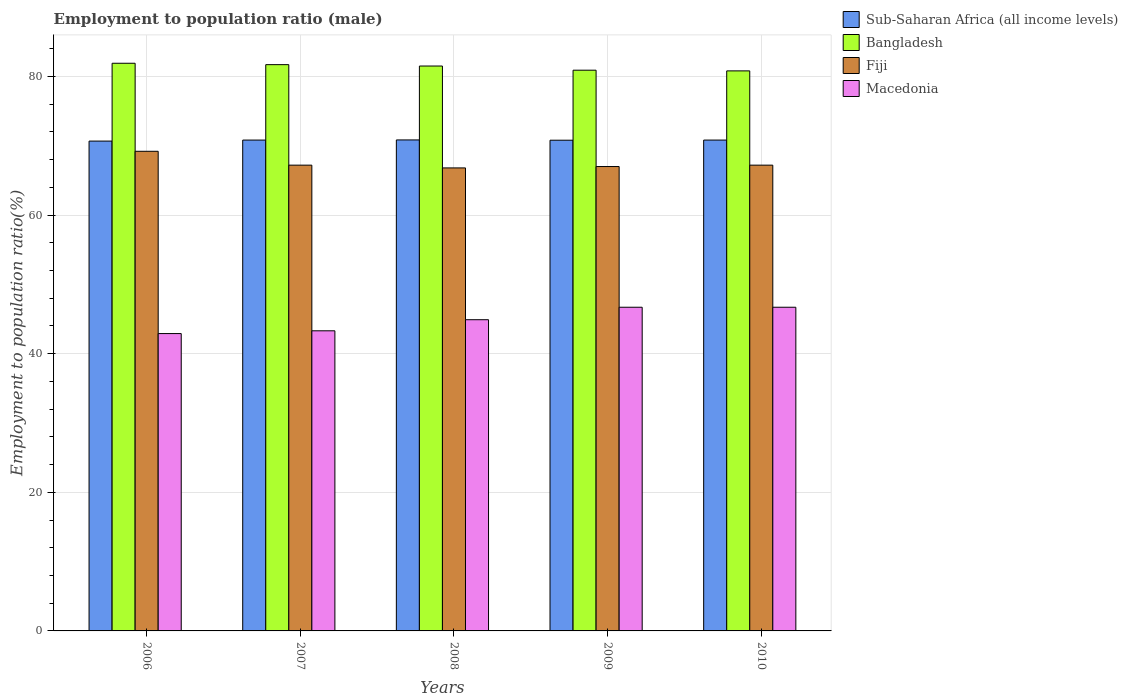How many groups of bars are there?
Your answer should be very brief. 5. Are the number of bars per tick equal to the number of legend labels?
Your answer should be very brief. Yes. How many bars are there on the 1st tick from the left?
Ensure brevity in your answer.  4. What is the label of the 2nd group of bars from the left?
Make the answer very short. 2007. In how many cases, is the number of bars for a given year not equal to the number of legend labels?
Keep it short and to the point. 0. What is the employment to population ratio in Macedonia in 2007?
Your response must be concise. 43.3. Across all years, what is the maximum employment to population ratio in Sub-Saharan Africa (all income levels)?
Offer a terse response. 70.84. Across all years, what is the minimum employment to population ratio in Bangladesh?
Your response must be concise. 80.8. In which year was the employment to population ratio in Fiji minimum?
Your answer should be compact. 2008. What is the total employment to population ratio in Fiji in the graph?
Keep it short and to the point. 337.4. What is the difference between the employment to population ratio in Fiji in 2007 and that in 2009?
Provide a short and direct response. 0.2. What is the difference between the employment to population ratio in Fiji in 2008 and the employment to population ratio in Macedonia in 2009?
Your answer should be very brief. 20.1. What is the average employment to population ratio in Fiji per year?
Your response must be concise. 67.48. In the year 2009, what is the difference between the employment to population ratio in Sub-Saharan Africa (all income levels) and employment to population ratio in Fiji?
Your answer should be very brief. 3.8. In how many years, is the employment to population ratio in Macedonia greater than 36 %?
Ensure brevity in your answer.  5. What is the ratio of the employment to population ratio in Macedonia in 2006 to that in 2010?
Your answer should be compact. 0.92. Is the difference between the employment to population ratio in Sub-Saharan Africa (all income levels) in 2006 and 2010 greater than the difference between the employment to population ratio in Fiji in 2006 and 2010?
Your response must be concise. No. What is the difference between the highest and the second highest employment to population ratio in Bangladesh?
Keep it short and to the point. 0.2. What is the difference between the highest and the lowest employment to population ratio in Bangladesh?
Your answer should be compact. 1.1. Is the sum of the employment to population ratio in Sub-Saharan Africa (all income levels) in 2007 and 2008 greater than the maximum employment to population ratio in Fiji across all years?
Offer a very short reply. Yes. What does the 1st bar from the left in 2006 represents?
Your response must be concise. Sub-Saharan Africa (all income levels). Is it the case that in every year, the sum of the employment to population ratio in Bangladesh and employment to population ratio in Macedonia is greater than the employment to population ratio in Sub-Saharan Africa (all income levels)?
Your response must be concise. Yes. How many bars are there?
Make the answer very short. 20. How many years are there in the graph?
Your answer should be compact. 5. Does the graph contain grids?
Your response must be concise. Yes. How are the legend labels stacked?
Keep it short and to the point. Vertical. What is the title of the graph?
Ensure brevity in your answer.  Employment to population ratio (male). Does "Korea (Democratic)" appear as one of the legend labels in the graph?
Offer a terse response. No. What is the label or title of the X-axis?
Offer a very short reply. Years. What is the Employment to population ratio(%) of Sub-Saharan Africa (all income levels) in 2006?
Ensure brevity in your answer.  70.67. What is the Employment to population ratio(%) in Bangladesh in 2006?
Provide a succinct answer. 81.9. What is the Employment to population ratio(%) in Fiji in 2006?
Offer a terse response. 69.2. What is the Employment to population ratio(%) in Macedonia in 2006?
Make the answer very short. 42.9. What is the Employment to population ratio(%) in Sub-Saharan Africa (all income levels) in 2007?
Your answer should be compact. 70.82. What is the Employment to population ratio(%) in Bangladesh in 2007?
Provide a succinct answer. 81.7. What is the Employment to population ratio(%) in Fiji in 2007?
Offer a terse response. 67.2. What is the Employment to population ratio(%) in Macedonia in 2007?
Offer a very short reply. 43.3. What is the Employment to population ratio(%) of Sub-Saharan Africa (all income levels) in 2008?
Give a very brief answer. 70.84. What is the Employment to population ratio(%) of Bangladesh in 2008?
Your answer should be very brief. 81.5. What is the Employment to population ratio(%) in Fiji in 2008?
Provide a short and direct response. 66.8. What is the Employment to population ratio(%) of Macedonia in 2008?
Give a very brief answer. 44.9. What is the Employment to population ratio(%) of Sub-Saharan Africa (all income levels) in 2009?
Offer a terse response. 70.8. What is the Employment to population ratio(%) in Bangladesh in 2009?
Your answer should be compact. 80.9. What is the Employment to population ratio(%) in Fiji in 2009?
Provide a short and direct response. 67. What is the Employment to population ratio(%) of Macedonia in 2009?
Give a very brief answer. 46.7. What is the Employment to population ratio(%) in Sub-Saharan Africa (all income levels) in 2010?
Offer a very short reply. 70.82. What is the Employment to population ratio(%) in Bangladesh in 2010?
Ensure brevity in your answer.  80.8. What is the Employment to population ratio(%) of Fiji in 2010?
Offer a terse response. 67.2. What is the Employment to population ratio(%) of Macedonia in 2010?
Ensure brevity in your answer.  46.7. Across all years, what is the maximum Employment to population ratio(%) in Sub-Saharan Africa (all income levels)?
Keep it short and to the point. 70.84. Across all years, what is the maximum Employment to population ratio(%) of Bangladesh?
Offer a terse response. 81.9. Across all years, what is the maximum Employment to population ratio(%) in Fiji?
Give a very brief answer. 69.2. Across all years, what is the maximum Employment to population ratio(%) of Macedonia?
Keep it short and to the point. 46.7. Across all years, what is the minimum Employment to population ratio(%) of Sub-Saharan Africa (all income levels)?
Ensure brevity in your answer.  70.67. Across all years, what is the minimum Employment to population ratio(%) in Bangladesh?
Make the answer very short. 80.8. Across all years, what is the minimum Employment to population ratio(%) of Fiji?
Your response must be concise. 66.8. Across all years, what is the minimum Employment to population ratio(%) in Macedonia?
Provide a short and direct response. 42.9. What is the total Employment to population ratio(%) in Sub-Saharan Africa (all income levels) in the graph?
Offer a terse response. 353.94. What is the total Employment to population ratio(%) of Bangladesh in the graph?
Offer a terse response. 406.8. What is the total Employment to population ratio(%) of Fiji in the graph?
Provide a short and direct response. 337.4. What is the total Employment to population ratio(%) in Macedonia in the graph?
Your answer should be compact. 224.5. What is the difference between the Employment to population ratio(%) in Sub-Saharan Africa (all income levels) in 2006 and that in 2007?
Make the answer very short. -0.15. What is the difference between the Employment to population ratio(%) of Fiji in 2006 and that in 2007?
Provide a succinct answer. 2. What is the difference between the Employment to population ratio(%) of Macedonia in 2006 and that in 2007?
Provide a short and direct response. -0.4. What is the difference between the Employment to population ratio(%) in Sub-Saharan Africa (all income levels) in 2006 and that in 2008?
Offer a very short reply. -0.17. What is the difference between the Employment to population ratio(%) of Macedonia in 2006 and that in 2008?
Ensure brevity in your answer.  -2. What is the difference between the Employment to population ratio(%) of Sub-Saharan Africa (all income levels) in 2006 and that in 2009?
Offer a terse response. -0.12. What is the difference between the Employment to population ratio(%) of Fiji in 2006 and that in 2009?
Your answer should be very brief. 2.2. What is the difference between the Employment to population ratio(%) of Sub-Saharan Africa (all income levels) in 2006 and that in 2010?
Provide a succinct answer. -0.15. What is the difference between the Employment to population ratio(%) of Bangladesh in 2006 and that in 2010?
Keep it short and to the point. 1.1. What is the difference between the Employment to population ratio(%) of Fiji in 2006 and that in 2010?
Your answer should be very brief. 2. What is the difference between the Employment to population ratio(%) in Sub-Saharan Africa (all income levels) in 2007 and that in 2008?
Your answer should be compact. -0.02. What is the difference between the Employment to population ratio(%) of Bangladesh in 2007 and that in 2008?
Offer a terse response. 0.2. What is the difference between the Employment to population ratio(%) in Fiji in 2007 and that in 2008?
Offer a very short reply. 0.4. What is the difference between the Employment to population ratio(%) of Sub-Saharan Africa (all income levels) in 2007 and that in 2009?
Make the answer very short. 0.02. What is the difference between the Employment to population ratio(%) in Bangladesh in 2007 and that in 2009?
Your answer should be compact. 0.8. What is the difference between the Employment to population ratio(%) of Fiji in 2007 and that in 2009?
Give a very brief answer. 0.2. What is the difference between the Employment to population ratio(%) in Macedonia in 2007 and that in 2009?
Ensure brevity in your answer.  -3.4. What is the difference between the Employment to population ratio(%) in Sub-Saharan Africa (all income levels) in 2007 and that in 2010?
Offer a very short reply. -0. What is the difference between the Employment to population ratio(%) of Bangladesh in 2007 and that in 2010?
Ensure brevity in your answer.  0.9. What is the difference between the Employment to population ratio(%) in Sub-Saharan Africa (all income levels) in 2008 and that in 2009?
Make the answer very short. 0.04. What is the difference between the Employment to population ratio(%) of Fiji in 2008 and that in 2009?
Make the answer very short. -0.2. What is the difference between the Employment to population ratio(%) in Sub-Saharan Africa (all income levels) in 2008 and that in 2010?
Provide a short and direct response. 0.02. What is the difference between the Employment to population ratio(%) in Bangladesh in 2008 and that in 2010?
Provide a short and direct response. 0.7. What is the difference between the Employment to population ratio(%) of Sub-Saharan Africa (all income levels) in 2009 and that in 2010?
Ensure brevity in your answer.  -0.02. What is the difference between the Employment to population ratio(%) of Bangladesh in 2009 and that in 2010?
Your answer should be very brief. 0.1. What is the difference between the Employment to population ratio(%) of Sub-Saharan Africa (all income levels) in 2006 and the Employment to population ratio(%) of Bangladesh in 2007?
Offer a very short reply. -11.03. What is the difference between the Employment to population ratio(%) of Sub-Saharan Africa (all income levels) in 2006 and the Employment to population ratio(%) of Fiji in 2007?
Ensure brevity in your answer.  3.47. What is the difference between the Employment to population ratio(%) in Sub-Saharan Africa (all income levels) in 2006 and the Employment to population ratio(%) in Macedonia in 2007?
Offer a terse response. 27.37. What is the difference between the Employment to population ratio(%) of Bangladesh in 2006 and the Employment to population ratio(%) of Macedonia in 2007?
Keep it short and to the point. 38.6. What is the difference between the Employment to population ratio(%) in Fiji in 2006 and the Employment to population ratio(%) in Macedonia in 2007?
Keep it short and to the point. 25.9. What is the difference between the Employment to population ratio(%) of Sub-Saharan Africa (all income levels) in 2006 and the Employment to population ratio(%) of Bangladesh in 2008?
Ensure brevity in your answer.  -10.83. What is the difference between the Employment to population ratio(%) in Sub-Saharan Africa (all income levels) in 2006 and the Employment to population ratio(%) in Fiji in 2008?
Offer a terse response. 3.87. What is the difference between the Employment to population ratio(%) of Sub-Saharan Africa (all income levels) in 2006 and the Employment to population ratio(%) of Macedonia in 2008?
Your answer should be very brief. 25.77. What is the difference between the Employment to population ratio(%) of Bangladesh in 2006 and the Employment to population ratio(%) of Fiji in 2008?
Your answer should be compact. 15.1. What is the difference between the Employment to population ratio(%) of Fiji in 2006 and the Employment to population ratio(%) of Macedonia in 2008?
Provide a succinct answer. 24.3. What is the difference between the Employment to population ratio(%) of Sub-Saharan Africa (all income levels) in 2006 and the Employment to population ratio(%) of Bangladesh in 2009?
Your response must be concise. -10.23. What is the difference between the Employment to population ratio(%) of Sub-Saharan Africa (all income levels) in 2006 and the Employment to population ratio(%) of Fiji in 2009?
Give a very brief answer. 3.67. What is the difference between the Employment to population ratio(%) of Sub-Saharan Africa (all income levels) in 2006 and the Employment to population ratio(%) of Macedonia in 2009?
Provide a succinct answer. 23.97. What is the difference between the Employment to population ratio(%) of Bangladesh in 2006 and the Employment to population ratio(%) of Fiji in 2009?
Offer a very short reply. 14.9. What is the difference between the Employment to population ratio(%) of Bangladesh in 2006 and the Employment to population ratio(%) of Macedonia in 2009?
Give a very brief answer. 35.2. What is the difference between the Employment to population ratio(%) in Fiji in 2006 and the Employment to population ratio(%) in Macedonia in 2009?
Make the answer very short. 22.5. What is the difference between the Employment to population ratio(%) in Sub-Saharan Africa (all income levels) in 2006 and the Employment to population ratio(%) in Bangladesh in 2010?
Keep it short and to the point. -10.13. What is the difference between the Employment to population ratio(%) in Sub-Saharan Africa (all income levels) in 2006 and the Employment to population ratio(%) in Fiji in 2010?
Provide a succinct answer. 3.47. What is the difference between the Employment to population ratio(%) of Sub-Saharan Africa (all income levels) in 2006 and the Employment to population ratio(%) of Macedonia in 2010?
Give a very brief answer. 23.97. What is the difference between the Employment to population ratio(%) in Bangladesh in 2006 and the Employment to population ratio(%) in Fiji in 2010?
Your answer should be compact. 14.7. What is the difference between the Employment to population ratio(%) in Bangladesh in 2006 and the Employment to population ratio(%) in Macedonia in 2010?
Your response must be concise. 35.2. What is the difference between the Employment to population ratio(%) of Sub-Saharan Africa (all income levels) in 2007 and the Employment to population ratio(%) of Bangladesh in 2008?
Offer a terse response. -10.68. What is the difference between the Employment to population ratio(%) in Sub-Saharan Africa (all income levels) in 2007 and the Employment to population ratio(%) in Fiji in 2008?
Make the answer very short. 4.02. What is the difference between the Employment to population ratio(%) of Sub-Saharan Africa (all income levels) in 2007 and the Employment to population ratio(%) of Macedonia in 2008?
Your answer should be very brief. 25.92. What is the difference between the Employment to population ratio(%) in Bangladesh in 2007 and the Employment to population ratio(%) in Macedonia in 2008?
Provide a short and direct response. 36.8. What is the difference between the Employment to population ratio(%) in Fiji in 2007 and the Employment to population ratio(%) in Macedonia in 2008?
Offer a very short reply. 22.3. What is the difference between the Employment to population ratio(%) in Sub-Saharan Africa (all income levels) in 2007 and the Employment to population ratio(%) in Bangladesh in 2009?
Your answer should be very brief. -10.08. What is the difference between the Employment to population ratio(%) of Sub-Saharan Africa (all income levels) in 2007 and the Employment to population ratio(%) of Fiji in 2009?
Make the answer very short. 3.82. What is the difference between the Employment to population ratio(%) of Sub-Saharan Africa (all income levels) in 2007 and the Employment to population ratio(%) of Macedonia in 2009?
Provide a short and direct response. 24.12. What is the difference between the Employment to population ratio(%) in Bangladesh in 2007 and the Employment to population ratio(%) in Fiji in 2009?
Provide a short and direct response. 14.7. What is the difference between the Employment to population ratio(%) in Fiji in 2007 and the Employment to population ratio(%) in Macedonia in 2009?
Your response must be concise. 20.5. What is the difference between the Employment to population ratio(%) of Sub-Saharan Africa (all income levels) in 2007 and the Employment to population ratio(%) of Bangladesh in 2010?
Your answer should be compact. -9.98. What is the difference between the Employment to population ratio(%) in Sub-Saharan Africa (all income levels) in 2007 and the Employment to population ratio(%) in Fiji in 2010?
Give a very brief answer. 3.62. What is the difference between the Employment to population ratio(%) of Sub-Saharan Africa (all income levels) in 2007 and the Employment to population ratio(%) of Macedonia in 2010?
Your response must be concise. 24.12. What is the difference between the Employment to population ratio(%) in Bangladesh in 2007 and the Employment to population ratio(%) in Macedonia in 2010?
Provide a succinct answer. 35. What is the difference between the Employment to population ratio(%) of Fiji in 2007 and the Employment to population ratio(%) of Macedonia in 2010?
Keep it short and to the point. 20.5. What is the difference between the Employment to population ratio(%) of Sub-Saharan Africa (all income levels) in 2008 and the Employment to population ratio(%) of Bangladesh in 2009?
Your answer should be compact. -10.06. What is the difference between the Employment to population ratio(%) in Sub-Saharan Africa (all income levels) in 2008 and the Employment to population ratio(%) in Fiji in 2009?
Keep it short and to the point. 3.84. What is the difference between the Employment to population ratio(%) in Sub-Saharan Africa (all income levels) in 2008 and the Employment to population ratio(%) in Macedonia in 2009?
Offer a terse response. 24.14. What is the difference between the Employment to population ratio(%) in Bangladesh in 2008 and the Employment to population ratio(%) in Fiji in 2009?
Your answer should be very brief. 14.5. What is the difference between the Employment to population ratio(%) of Bangladesh in 2008 and the Employment to population ratio(%) of Macedonia in 2009?
Offer a very short reply. 34.8. What is the difference between the Employment to population ratio(%) in Fiji in 2008 and the Employment to population ratio(%) in Macedonia in 2009?
Give a very brief answer. 20.1. What is the difference between the Employment to population ratio(%) of Sub-Saharan Africa (all income levels) in 2008 and the Employment to population ratio(%) of Bangladesh in 2010?
Offer a very short reply. -9.96. What is the difference between the Employment to population ratio(%) of Sub-Saharan Africa (all income levels) in 2008 and the Employment to population ratio(%) of Fiji in 2010?
Offer a very short reply. 3.64. What is the difference between the Employment to population ratio(%) in Sub-Saharan Africa (all income levels) in 2008 and the Employment to population ratio(%) in Macedonia in 2010?
Make the answer very short. 24.14. What is the difference between the Employment to population ratio(%) in Bangladesh in 2008 and the Employment to population ratio(%) in Fiji in 2010?
Give a very brief answer. 14.3. What is the difference between the Employment to population ratio(%) in Bangladesh in 2008 and the Employment to population ratio(%) in Macedonia in 2010?
Provide a succinct answer. 34.8. What is the difference between the Employment to population ratio(%) of Fiji in 2008 and the Employment to population ratio(%) of Macedonia in 2010?
Offer a terse response. 20.1. What is the difference between the Employment to population ratio(%) of Sub-Saharan Africa (all income levels) in 2009 and the Employment to population ratio(%) of Bangladesh in 2010?
Ensure brevity in your answer.  -10. What is the difference between the Employment to population ratio(%) of Sub-Saharan Africa (all income levels) in 2009 and the Employment to population ratio(%) of Fiji in 2010?
Provide a succinct answer. 3.6. What is the difference between the Employment to population ratio(%) in Sub-Saharan Africa (all income levels) in 2009 and the Employment to population ratio(%) in Macedonia in 2010?
Provide a succinct answer. 24.1. What is the difference between the Employment to population ratio(%) in Bangladesh in 2009 and the Employment to population ratio(%) in Fiji in 2010?
Keep it short and to the point. 13.7. What is the difference between the Employment to population ratio(%) in Bangladesh in 2009 and the Employment to population ratio(%) in Macedonia in 2010?
Ensure brevity in your answer.  34.2. What is the difference between the Employment to population ratio(%) of Fiji in 2009 and the Employment to population ratio(%) of Macedonia in 2010?
Your answer should be very brief. 20.3. What is the average Employment to population ratio(%) in Sub-Saharan Africa (all income levels) per year?
Offer a very short reply. 70.79. What is the average Employment to population ratio(%) in Bangladesh per year?
Provide a succinct answer. 81.36. What is the average Employment to population ratio(%) of Fiji per year?
Offer a terse response. 67.48. What is the average Employment to population ratio(%) in Macedonia per year?
Provide a short and direct response. 44.9. In the year 2006, what is the difference between the Employment to population ratio(%) of Sub-Saharan Africa (all income levels) and Employment to population ratio(%) of Bangladesh?
Provide a short and direct response. -11.23. In the year 2006, what is the difference between the Employment to population ratio(%) of Sub-Saharan Africa (all income levels) and Employment to population ratio(%) of Fiji?
Keep it short and to the point. 1.47. In the year 2006, what is the difference between the Employment to population ratio(%) in Sub-Saharan Africa (all income levels) and Employment to population ratio(%) in Macedonia?
Keep it short and to the point. 27.77. In the year 2006, what is the difference between the Employment to population ratio(%) of Bangladesh and Employment to population ratio(%) of Macedonia?
Ensure brevity in your answer.  39. In the year 2006, what is the difference between the Employment to population ratio(%) of Fiji and Employment to population ratio(%) of Macedonia?
Ensure brevity in your answer.  26.3. In the year 2007, what is the difference between the Employment to population ratio(%) of Sub-Saharan Africa (all income levels) and Employment to population ratio(%) of Bangladesh?
Your answer should be compact. -10.88. In the year 2007, what is the difference between the Employment to population ratio(%) of Sub-Saharan Africa (all income levels) and Employment to population ratio(%) of Fiji?
Your answer should be very brief. 3.62. In the year 2007, what is the difference between the Employment to population ratio(%) of Sub-Saharan Africa (all income levels) and Employment to population ratio(%) of Macedonia?
Ensure brevity in your answer.  27.52. In the year 2007, what is the difference between the Employment to population ratio(%) of Bangladesh and Employment to population ratio(%) of Fiji?
Your answer should be compact. 14.5. In the year 2007, what is the difference between the Employment to population ratio(%) in Bangladesh and Employment to population ratio(%) in Macedonia?
Keep it short and to the point. 38.4. In the year 2007, what is the difference between the Employment to population ratio(%) of Fiji and Employment to population ratio(%) of Macedonia?
Ensure brevity in your answer.  23.9. In the year 2008, what is the difference between the Employment to population ratio(%) of Sub-Saharan Africa (all income levels) and Employment to population ratio(%) of Bangladesh?
Give a very brief answer. -10.66. In the year 2008, what is the difference between the Employment to population ratio(%) of Sub-Saharan Africa (all income levels) and Employment to population ratio(%) of Fiji?
Ensure brevity in your answer.  4.04. In the year 2008, what is the difference between the Employment to population ratio(%) in Sub-Saharan Africa (all income levels) and Employment to population ratio(%) in Macedonia?
Provide a short and direct response. 25.94. In the year 2008, what is the difference between the Employment to population ratio(%) of Bangladesh and Employment to population ratio(%) of Macedonia?
Offer a terse response. 36.6. In the year 2008, what is the difference between the Employment to population ratio(%) in Fiji and Employment to population ratio(%) in Macedonia?
Offer a terse response. 21.9. In the year 2009, what is the difference between the Employment to population ratio(%) in Sub-Saharan Africa (all income levels) and Employment to population ratio(%) in Bangladesh?
Ensure brevity in your answer.  -10.1. In the year 2009, what is the difference between the Employment to population ratio(%) in Sub-Saharan Africa (all income levels) and Employment to population ratio(%) in Fiji?
Your response must be concise. 3.8. In the year 2009, what is the difference between the Employment to population ratio(%) of Sub-Saharan Africa (all income levels) and Employment to population ratio(%) of Macedonia?
Provide a short and direct response. 24.1. In the year 2009, what is the difference between the Employment to population ratio(%) in Bangladesh and Employment to population ratio(%) in Fiji?
Give a very brief answer. 13.9. In the year 2009, what is the difference between the Employment to population ratio(%) of Bangladesh and Employment to population ratio(%) of Macedonia?
Provide a succinct answer. 34.2. In the year 2009, what is the difference between the Employment to population ratio(%) in Fiji and Employment to population ratio(%) in Macedonia?
Your answer should be compact. 20.3. In the year 2010, what is the difference between the Employment to population ratio(%) in Sub-Saharan Africa (all income levels) and Employment to population ratio(%) in Bangladesh?
Make the answer very short. -9.98. In the year 2010, what is the difference between the Employment to population ratio(%) in Sub-Saharan Africa (all income levels) and Employment to population ratio(%) in Fiji?
Give a very brief answer. 3.62. In the year 2010, what is the difference between the Employment to population ratio(%) of Sub-Saharan Africa (all income levels) and Employment to population ratio(%) of Macedonia?
Your answer should be very brief. 24.12. In the year 2010, what is the difference between the Employment to population ratio(%) in Bangladesh and Employment to population ratio(%) in Macedonia?
Your answer should be very brief. 34.1. In the year 2010, what is the difference between the Employment to population ratio(%) of Fiji and Employment to population ratio(%) of Macedonia?
Offer a very short reply. 20.5. What is the ratio of the Employment to population ratio(%) of Bangladesh in 2006 to that in 2007?
Your answer should be compact. 1. What is the ratio of the Employment to population ratio(%) of Fiji in 2006 to that in 2007?
Your response must be concise. 1.03. What is the ratio of the Employment to population ratio(%) in Fiji in 2006 to that in 2008?
Provide a short and direct response. 1.04. What is the ratio of the Employment to population ratio(%) of Macedonia in 2006 to that in 2008?
Ensure brevity in your answer.  0.96. What is the ratio of the Employment to population ratio(%) in Sub-Saharan Africa (all income levels) in 2006 to that in 2009?
Provide a succinct answer. 1. What is the ratio of the Employment to population ratio(%) of Bangladesh in 2006 to that in 2009?
Offer a terse response. 1.01. What is the ratio of the Employment to population ratio(%) in Fiji in 2006 to that in 2009?
Ensure brevity in your answer.  1.03. What is the ratio of the Employment to population ratio(%) in Macedonia in 2006 to that in 2009?
Keep it short and to the point. 0.92. What is the ratio of the Employment to population ratio(%) of Sub-Saharan Africa (all income levels) in 2006 to that in 2010?
Your answer should be very brief. 1. What is the ratio of the Employment to population ratio(%) in Bangladesh in 2006 to that in 2010?
Make the answer very short. 1.01. What is the ratio of the Employment to population ratio(%) in Fiji in 2006 to that in 2010?
Provide a short and direct response. 1.03. What is the ratio of the Employment to population ratio(%) in Macedonia in 2006 to that in 2010?
Offer a terse response. 0.92. What is the ratio of the Employment to population ratio(%) in Sub-Saharan Africa (all income levels) in 2007 to that in 2008?
Your answer should be compact. 1. What is the ratio of the Employment to population ratio(%) in Bangladesh in 2007 to that in 2008?
Keep it short and to the point. 1. What is the ratio of the Employment to population ratio(%) of Macedonia in 2007 to that in 2008?
Your response must be concise. 0.96. What is the ratio of the Employment to population ratio(%) in Bangladesh in 2007 to that in 2009?
Give a very brief answer. 1.01. What is the ratio of the Employment to population ratio(%) of Macedonia in 2007 to that in 2009?
Give a very brief answer. 0.93. What is the ratio of the Employment to population ratio(%) in Bangladesh in 2007 to that in 2010?
Your answer should be very brief. 1.01. What is the ratio of the Employment to population ratio(%) of Macedonia in 2007 to that in 2010?
Offer a very short reply. 0.93. What is the ratio of the Employment to population ratio(%) in Sub-Saharan Africa (all income levels) in 2008 to that in 2009?
Keep it short and to the point. 1. What is the ratio of the Employment to population ratio(%) of Bangladesh in 2008 to that in 2009?
Your answer should be very brief. 1.01. What is the ratio of the Employment to population ratio(%) in Fiji in 2008 to that in 2009?
Your answer should be very brief. 1. What is the ratio of the Employment to population ratio(%) in Macedonia in 2008 to that in 2009?
Your answer should be compact. 0.96. What is the ratio of the Employment to population ratio(%) of Bangladesh in 2008 to that in 2010?
Keep it short and to the point. 1.01. What is the ratio of the Employment to population ratio(%) in Macedonia in 2008 to that in 2010?
Your answer should be compact. 0.96. What is the ratio of the Employment to population ratio(%) in Sub-Saharan Africa (all income levels) in 2009 to that in 2010?
Make the answer very short. 1. What is the ratio of the Employment to population ratio(%) in Bangladesh in 2009 to that in 2010?
Offer a very short reply. 1. What is the difference between the highest and the second highest Employment to population ratio(%) in Sub-Saharan Africa (all income levels)?
Provide a short and direct response. 0.02. What is the difference between the highest and the second highest Employment to population ratio(%) in Bangladesh?
Provide a short and direct response. 0.2. What is the difference between the highest and the second highest Employment to population ratio(%) of Macedonia?
Your answer should be very brief. 0. What is the difference between the highest and the lowest Employment to population ratio(%) in Sub-Saharan Africa (all income levels)?
Make the answer very short. 0.17. 